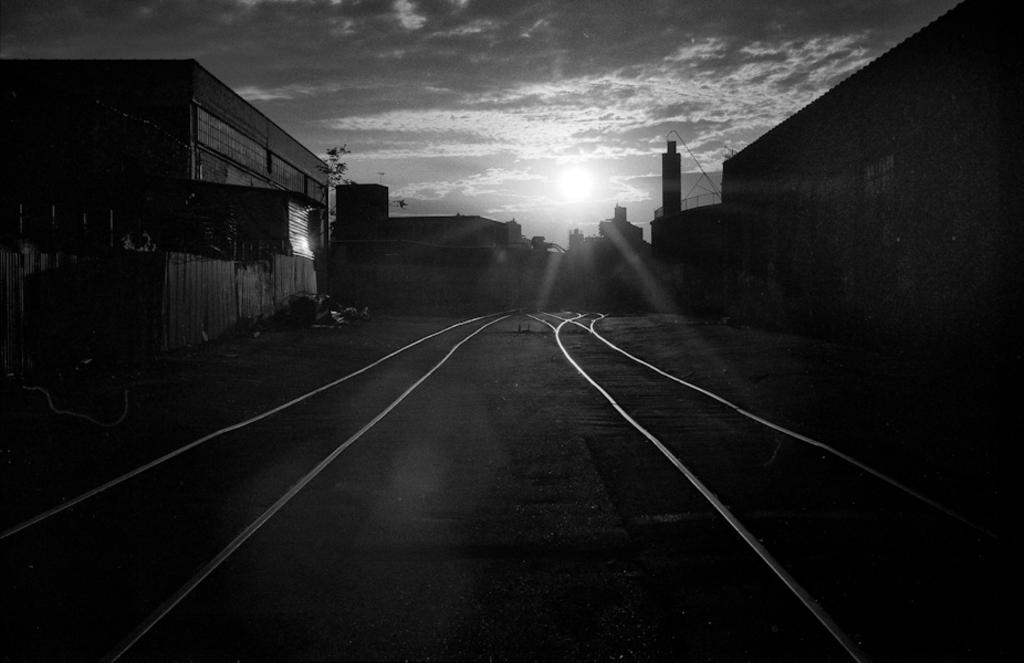What is the color scheme of the image? The image is black and white. What can be seen running through the center of the image? There are railway tracks in the image. What type of structures are located on both sides of the tracks? There are buildings on both sides of the tracks. What is the position of the sun in the image? The sun is in the center of the image. How would you describe the overall lighting in the image? The background of the image is dark. Can you tell me what request the stranger makes in the image? There is no stranger present in the image, so it is not possible to answer that question. 